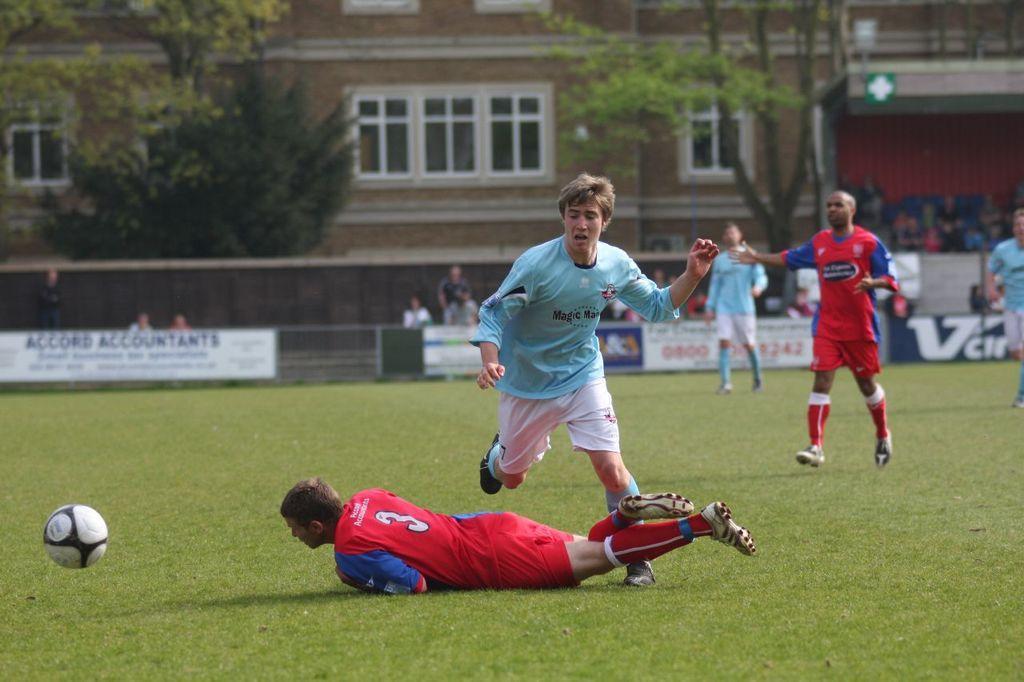In one or two sentences, can you explain what this image depicts? In this image there are few people playing football on the ground, there is a ball, some posters attached to the fence, there are few people in the stands and behind the fence, a building, few trees, few windows and a poster attached to the stands 